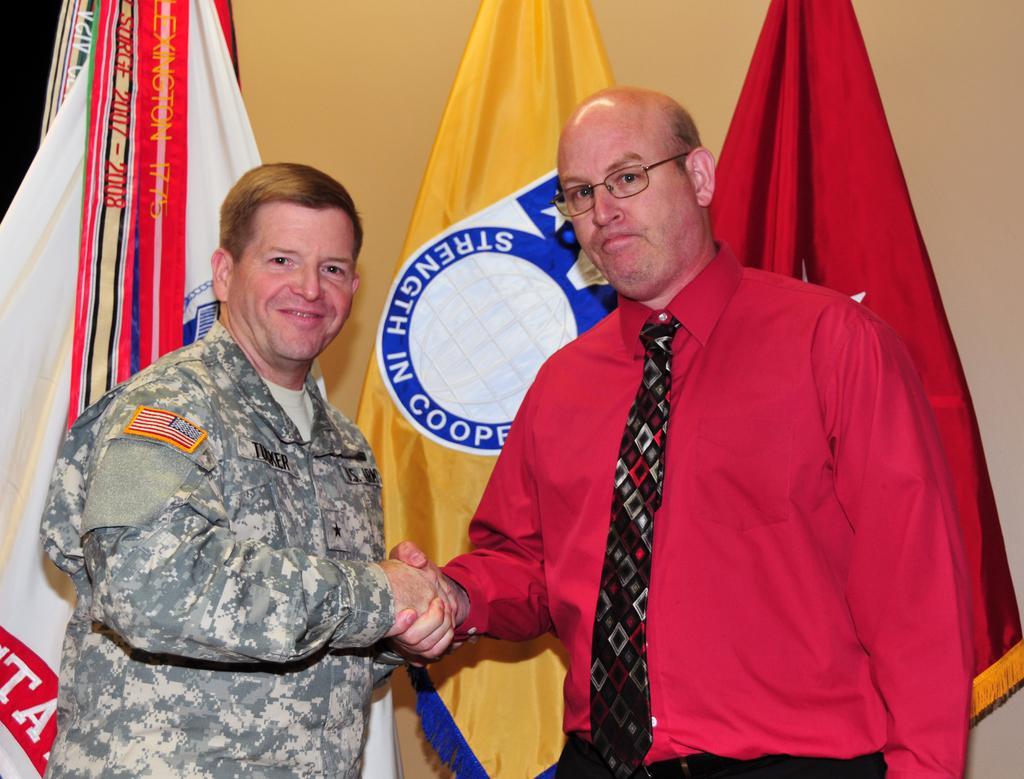Please provide a concise description of this image. In this image I can see two men are standing, shaking their hands, smiling and giving pose for the picture. The man who is on the right side is wearing a red color shirt, black color tie. The man who is on the left side is wearing uniform. At the back of these people I can see few flags and wall. 